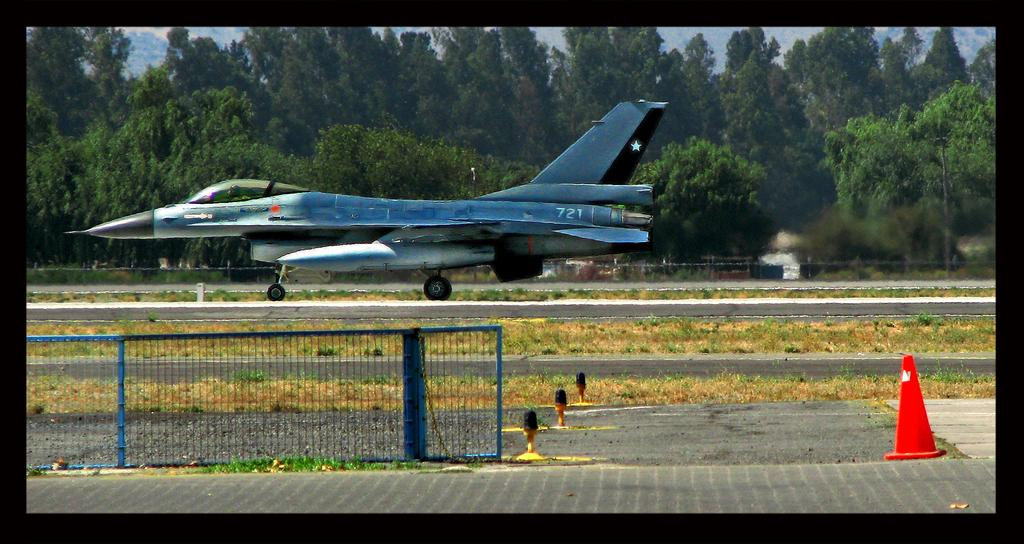What can be seen in the sky in the image? The sky with clouds is visible in the image. What type of vegetation is present in the image? There are trees in the image. What objects are used for cooking in the image? Grills are present in the image. What mode of transportation can be seen in the image? An aeroplane is visible in the image. What safety object is in the image? A traffic cone is in the image. What objects are used to separate traffic in the image? Barrier poles are present in the image. What type of surface is visible in the image? There is a road in the image. What type of ground cover is visible in the image? Grass is visible in the image. Where is the store located in the image? There is no store present in the image. What type of animal is grazing on the grass in the image? There is no animal present in the image, let alone a yak. 